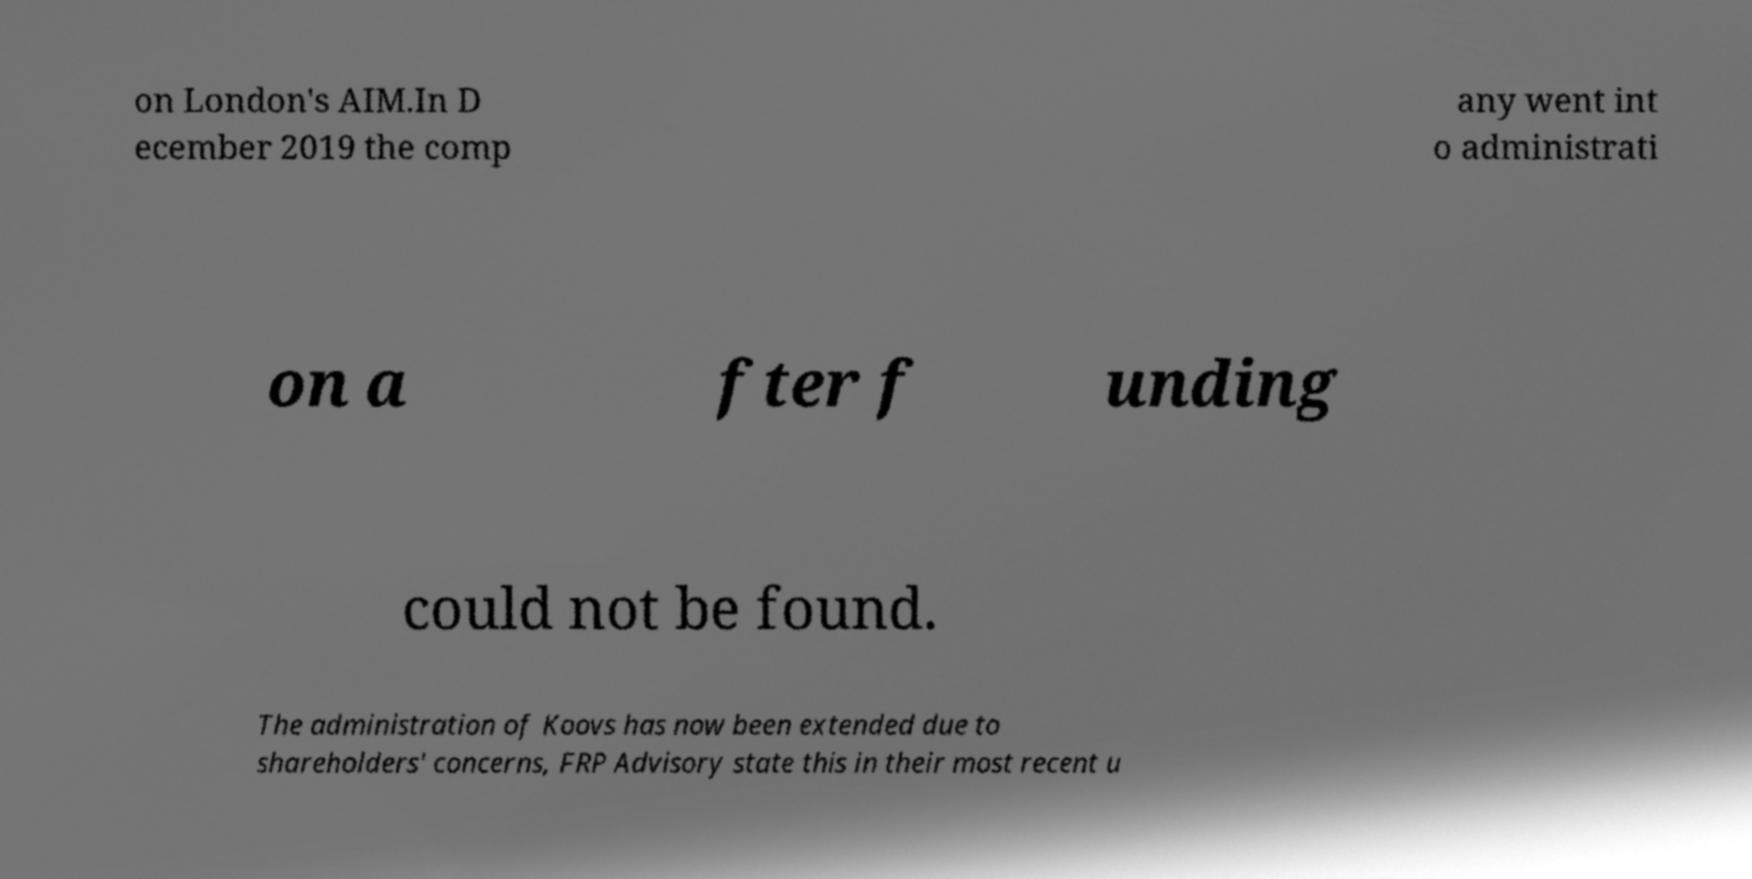Could you extract and type out the text from this image? on London's AIM.In D ecember 2019 the comp any went int o administrati on a fter f unding could not be found. The administration of Koovs has now been extended due to shareholders' concerns, FRP Advisory state this in their most recent u 